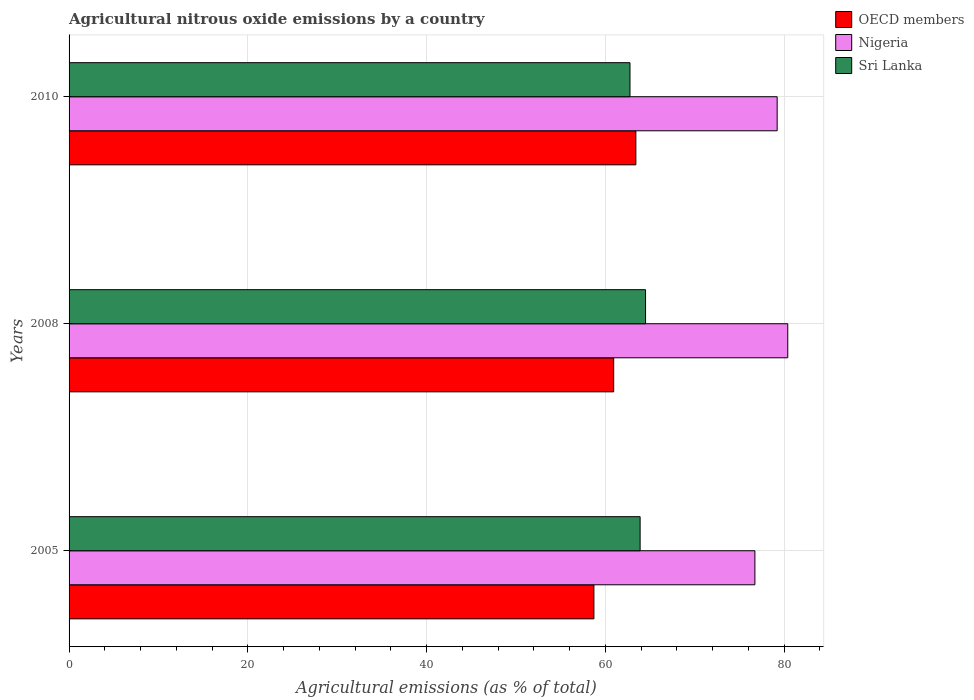How many different coloured bars are there?
Ensure brevity in your answer.  3. How many groups of bars are there?
Ensure brevity in your answer.  3. What is the label of the 3rd group of bars from the top?
Ensure brevity in your answer.  2005. In how many cases, is the number of bars for a given year not equal to the number of legend labels?
Offer a terse response. 0. What is the amount of agricultural nitrous oxide emitted in Sri Lanka in 2008?
Keep it short and to the point. 64.51. Across all years, what is the maximum amount of agricultural nitrous oxide emitted in Sri Lanka?
Offer a very short reply. 64.51. Across all years, what is the minimum amount of agricultural nitrous oxide emitted in Nigeria?
Your answer should be compact. 76.74. What is the total amount of agricultural nitrous oxide emitted in OECD members in the graph?
Provide a succinct answer. 183.09. What is the difference between the amount of agricultural nitrous oxide emitted in OECD members in 2008 and that in 2010?
Ensure brevity in your answer.  -2.48. What is the difference between the amount of agricultural nitrous oxide emitted in Nigeria in 2010 and the amount of agricultural nitrous oxide emitted in OECD members in 2005?
Your answer should be very brief. 20.5. What is the average amount of agricultural nitrous oxide emitted in Sri Lanka per year?
Offer a very short reply. 63.72. In the year 2005, what is the difference between the amount of agricultural nitrous oxide emitted in Nigeria and amount of agricultural nitrous oxide emitted in Sri Lanka?
Keep it short and to the point. 12.84. What is the ratio of the amount of agricultural nitrous oxide emitted in Nigeria in 2008 to that in 2010?
Provide a succinct answer. 1.01. Is the difference between the amount of agricultural nitrous oxide emitted in Nigeria in 2005 and 2010 greater than the difference between the amount of agricultural nitrous oxide emitted in Sri Lanka in 2005 and 2010?
Give a very brief answer. No. What is the difference between the highest and the second highest amount of agricultural nitrous oxide emitted in Nigeria?
Provide a short and direct response. 1.19. What is the difference between the highest and the lowest amount of agricultural nitrous oxide emitted in OECD members?
Make the answer very short. 4.69. Is it the case that in every year, the sum of the amount of agricultural nitrous oxide emitted in Nigeria and amount of agricultural nitrous oxide emitted in OECD members is greater than the amount of agricultural nitrous oxide emitted in Sri Lanka?
Give a very brief answer. Yes. How many bars are there?
Offer a very short reply. 9. Are all the bars in the graph horizontal?
Provide a succinct answer. Yes. How many years are there in the graph?
Your response must be concise. 3. What is the difference between two consecutive major ticks on the X-axis?
Offer a very short reply. 20. Does the graph contain any zero values?
Your answer should be very brief. No. Does the graph contain grids?
Make the answer very short. Yes. How are the legend labels stacked?
Offer a very short reply. Vertical. What is the title of the graph?
Give a very brief answer. Agricultural nitrous oxide emissions by a country. What is the label or title of the X-axis?
Offer a terse response. Agricultural emissions (as % of total). What is the label or title of the Y-axis?
Your answer should be very brief. Years. What is the Agricultural emissions (as % of total) in OECD members in 2005?
Ensure brevity in your answer.  58.73. What is the Agricultural emissions (as % of total) in Nigeria in 2005?
Offer a terse response. 76.74. What is the Agricultural emissions (as % of total) of Sri Lanka in 2005?
Give a very brief answer. 63.9. What is the Agricultural emissions (as % of total) in OECD members in 2008?
Give a very brief answer. 60.94. What is the Agricultural emissions (as % of total) of Nigeria in 2008?
Make the answer very short. 80.42. What is the Agricultural emissions (as % of total) in Sri Lanka in 2008?
Offer a terse response. 64.51. What is the Agricultural emissions (as % of total) in OECD members in 2010?
Ensure brevity in your answer.  63.42. What is the Agricultural emissions (as % of total) in Nigeria in 2010?
Offer a very short reply. 79.23. What is the Agricultural emissions (as % of total) in Sri Lanka in 2010?
Ensure brevity in your answer.  62.77. Across all years, what is the maximum Agricultural emissions (as % of total) in OECD members?
Offer a terse response. 63.42. Across all years, what is the maximum Agricultural emissions (as % of total) in Nigeria?
Your answer should be very brief. 80.42. Across all years, what is the maximum Agricultural emissions (as % of total) in Sri Lanka?
Keep it short and to the point. 64.51. Across all years, what is the minimum Agricultural emissions (as % of total) in OECD members?
Your answer should be compact. 58.73. Across all years, what is the minimum Agricultural emissions (as % of total) of Nigeria?
Give a very brief answer. 76.74. Across all years, what is the minimum Agricultural emissions (as % of total) of Sri Lanka?
Provide a succinct answer. 62.77. What is the total Agricultural emissions (as % of total) of OECD members in the graph?
Give a very brief answer. 183.09. What is the total Agricultural emissions (as % of total) in Nigeria in the graph?
Give a very brief answer. 236.4. What is the total Agricultural emissions (as % of total) in Sri Lanka in the graph?
Your response must be concise. 191.17. What is the difference between the Agricultural emissions (as % of total) of OECD members in 2005 and that in 2008?
Offer a terse response. -2.21. What is the difference between the Agricultural emissions (as % of total) in Nigeria in 2005 and that in 2008?
Keep it short and to the point. -3.68. What is the difference between the Agricultural emissions (as % of total) of Sri Lanka in 2005 and that in 2008?
Your response must be concise. -0.61. What is the difference between the Agricultural emissions (as % of total) in OECD members in 2005 and that in 2010?
Your response must be concise. -4.69. What is the difference between the Agricultural emissions (as % of total) of Nigeria in 2005 and that in 2010?
Your answer should be compact. -2.49. What is the difference between the Agricultural emissions (as % of total) of Sri Lanka in 2005 and that in 2010?
Offer a terse response. 1.13. What is the difference between the Agricultural emissions (as % of total) in OECD members in 2008 and that in 2010?
Offer a terse response. -2.48. What is the difference between the Agricultural emissions (as % of total) in Nigeria in 2008 and that in 2010?
Offer a terse response. 1.19. What is the difference between the Agricultural emissions (as % of total) in Sri Lanka in 2008 and that in 2010?
Make the answer very short. 1.74. What is the difference between the Agricultural emissions (as % of total) of OECD members in 2005 and the Agricultural emissions (as % of total) of Nigeria in 2008?
Provide a succinct answer. -21.69. What is the difference between the Agricultural emissions (as % of total) in OECD members in 2005 and the Agricultural emissions (as % of total) in Sri Lanka in 2008?
Provide a succinct answer. -5.78. What is the difference between the Agricultural emissions (as % of total) of Nigeria in 2005 and the Agricultural emissions (as % of total) of Sri Lanka in 2008?
Offer a very short reply. 12.24. What is the difference between the Agricultural emissions (as % of total) in OECD members in 2005 and the Agricultural emissions (as % of total) in Nigeria in 2010?
Keep it short and to the point. -20.5. What is the difference between the Agricultural emissions (as % of total) in OECD members in 2005 and the Agricultural emissions (as % of total) in Sri Lanka in 2010?
Keep it short and to the point. -4.04. What is the difference between the Agricultural emissions (as % of total) in Nigeria in 2005 and the Agricultural emissions (as % of total) in Sri Lanka in 2010?
Your answer should be compact. 13.98. What is the difference between the Agricultural emissions (as % of total) in OECD members in 2008 and the Agricultural emissions (as % of total) in Nigeria in 2010?
Provide a short and direct response. -18.29. What is the difference between the Agricultural emissions (as % of total) in OECD members in 2008 and the Agricultural emissions (as % of total) in Sri Lanka in 2010?
Ensure brevity in your answer.  -1.82. What is the difference between the Agricultural emissions (as % of total) in Nigeria in 2008 and the Agricultural emissions (as % of total) in Sri Lanka in 2010?
Offer a terse response. 17.65. What is the average Agricultural emissions (as % of total) in OECD members per year?
Provide a short and direct response. 61.03. What is the average Agricultural emissions (as % of total) in Nigeria per year?
Your answer should be compact. 78.8. What is the average Agricultural emissions (as % of total) in Sri Lanka per year?
Ensure brevity in your answer.  63.72. In the year 2005, what is the difference between the Agricultural emissions (as % of total) of OECD members and Agricultural emissions (as % of total) of Nigeria?
Offer a terse response. -18.02. In the year 2005, what is the difference between the Agricultural emissions (as % of total) in OECD members and Agricultural emissions (as % of total) in Sri Lanka?
Your answer should be very brief. -5.17. In the year 2005, what is the difference between the Agricultural emissions (as % of total) in Nigeria and Agricultural emissions (as % of total) in Sri Lanka?
Your answer should be very brief. 12.85. In the year 2008, what is the difference between the Agricultural emissions (as % of total) of OECD members and Agricultural emissions (as % of total) of Nigeria?
Make the answer very short. -19.48. In the year 2008, what is the difference between the Agricultural emissions (as % of total) of OECD members and Agricultural emissions (as % of total) of Sri Lanka?
Give a very brief answer. -3.56. In the year 2008, what is the difference between the Agricultural emissions (as % of total) of Nigeria and Agricultural emissions (as % of total) of Sri Lanka?
Your answer should be very brief. 15.91. In the year 2010, what is the difference between the Agricultural emissions (as % of total) in OECD members and Agricultural emissions (as % of total) in Nigeria?
Provide a short and direct response. -15.81. In the year 2010, what is the difference between the Agricultural emissions (as % of total) in OECD members and Agricultural emissions (as % of total) in Sri Lanka?
Offer a very short reply. 0.66. In the year 2010, what is the difference between the Agricultural emissions (as % of total) of Nigeria and Agricultural emissions (as % of total) of Sri Lanka?
Provide a short and direct response. 16.47. What is the ratio of the Agricultural emissions (as % of total) of OECD members in 2005 to that in 2008?
Make the answer very short. 0.96. What is the ratio of the Agricultural emissions (as % of total) in Nigeria in 2005 to that in 2008?
Your response must be concise. 0.95. What is the ratio of the Agricultural emissions (as % of total) in Sri Lanka in 2005 to that in 2008?
Provide a short and direct response. 0.99. What is the ratio of the Agricultural emissions (as % of total) in OECD members in 2005 to that in 2010?
Provide a short and direct response. 0.93. What is the ratio of the Agricultural emissions (as % of total) of Nigeria in 2005 to that in 2010?
Offer a very short reply. 0.97. What is the ratio of the Agricultural emissions (as % of total) of Sri Lanka in 2005 to that in 2010?
Make the answer very short. 1.02. What is the ratio of the Agricultural emissions (as % of total) of OECD members in 2008 to that in 2010?
Offer a terse response. 0.96. What is the ratio of the Agricultural emissions (as % of total) of Nigeria in 2008 to that in 2010?
Provide a short and direct response. 1.01. What is the ratio of the Agricultural emissions (as % of total) in Sri Lanka in 2008 to that in 2010?
Provide a short and direct response. 1.03. What is the difference between the highest and the second highest Agricultural emissions (as % of total) of OECD members?
Offer a terse response. 2.48. What is the difference between the highest and the second highest Agricultural emissions (as % of total) in Nigeria?
Give a very brief answer. 1.19. What is the difference between the highest and the second highest Agricultural emissions (as % of total) of Sri Lanka?
Make the answer very short. 0.61. What is the difference between the highest and the lowest Agricultural emissions (as % of total) in OECD members?
Give a very brief answer. 4.69. What is the difference between the highest and the lowest Agricultural emissions (as % of total) of Nigeria?
Give a very brief answer. 3.68. What is the difference between the highest and the lowest Agricultural emissions (as % of total) of Sri Lanka?
Provide a succinct answer. 1.74. 